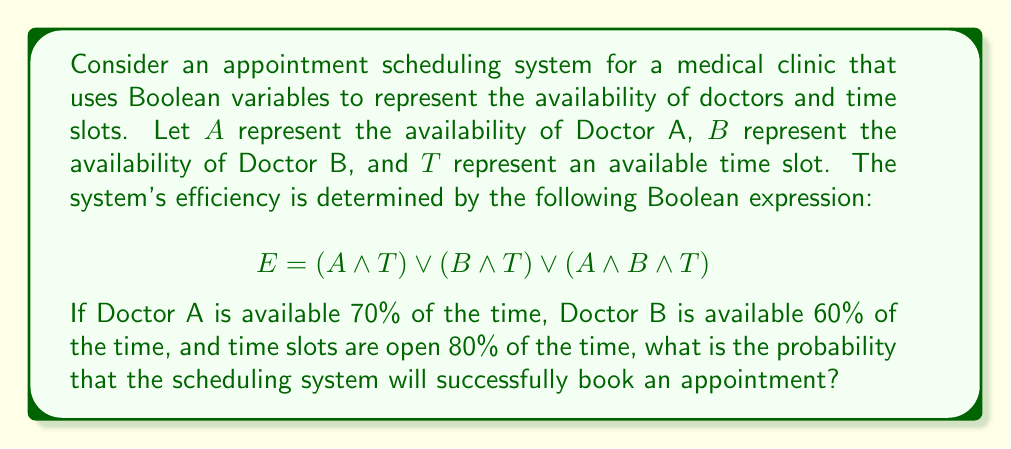Could you help me with this problem? To solve this problem, we need to use Boolean algebra and probability theory. Let's break it down step by step:

1) First, we need to simplify the Boolean expression for efficiency (E):
   $E = (A \land T) \lor (B \land T) \lor (A \land B \land T)$
   $= T \land (A \lor B \lor (A \land B))$
   $= T \land (A \lor B)$ (using the absorption law)

2) Now, we can interpret this as: an appointment can be scheduled if there's an available time slot AND either Doctor A or Doctor B (or both) are available.

3) Let's calculate the probabilities:
   $P(A) = 0.70$
   $P(B) = 0.60$
   $P(T) = 0.80$

4) We need to find $P(A \lor B)$:
   $P(A \lor B) = P(A) + P(B) - P(A \land B)$
   $= 0.70 + 0.60 - (0.70 \times 0.60)$
   $= 1.30 - 0.42 = 0.88$

5) Now, we can calculate the probability of a successful appointment:
   $P(E) = P(T) \times P(A \lor B)$
   $= 0.80 \times 0.88$
   $= 0.704$

Therefore, the probability that the scheduling system will successfully book an appointment is 0.704 or 70.4%.
Answer: 0.704 or 70.4% 